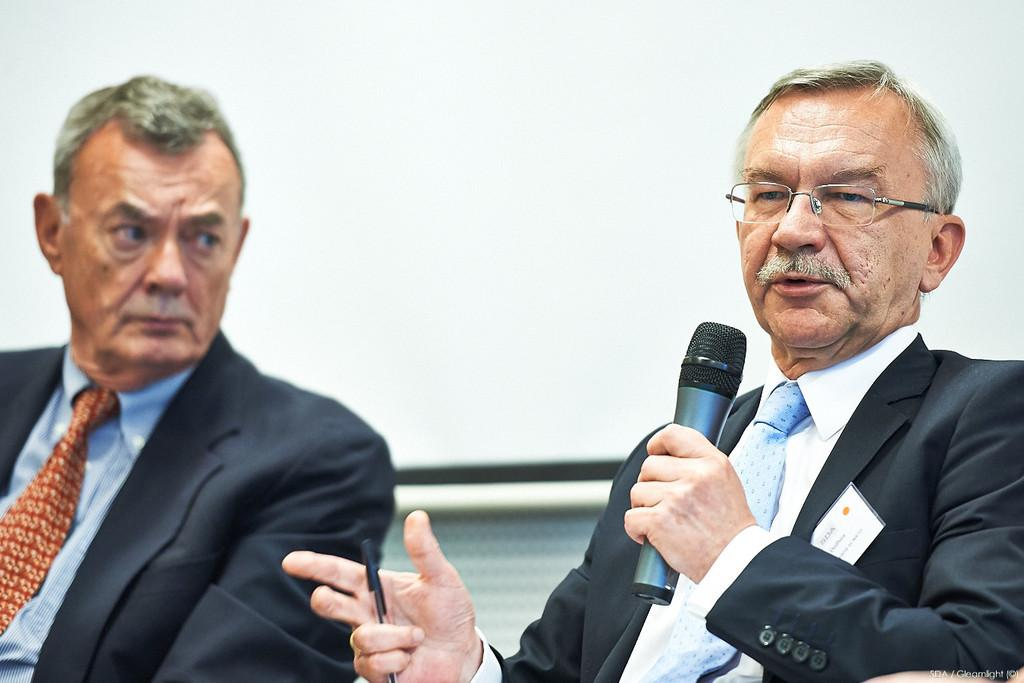How many people are present in the image? There are two people sitting in the image. What is one person doing in the image? One person is holding a microphone and speaking. Can you describe the person holding the microphone? The person holding the microphone has a badge attached to their suit and is also holding a pen in their hand. What is the color of the background in the image? The background of the image is white in color. How many boxes can be seen stacked in the background of the image? There are no boxes present in the image; the background is white. What type of harmony is being played by the person holding the microphone? There is no indication of music or harmony in the image; the person is simply speaking into a microphone. 